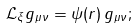Convert formula to latex. <formula><loc_0><loc_0><loc_500><loc_500>\mathcal { L _ { \xi } } g _ { \mu \nu } = \psi ( r ) \, g _ { \mu \nu } ;</formula> 